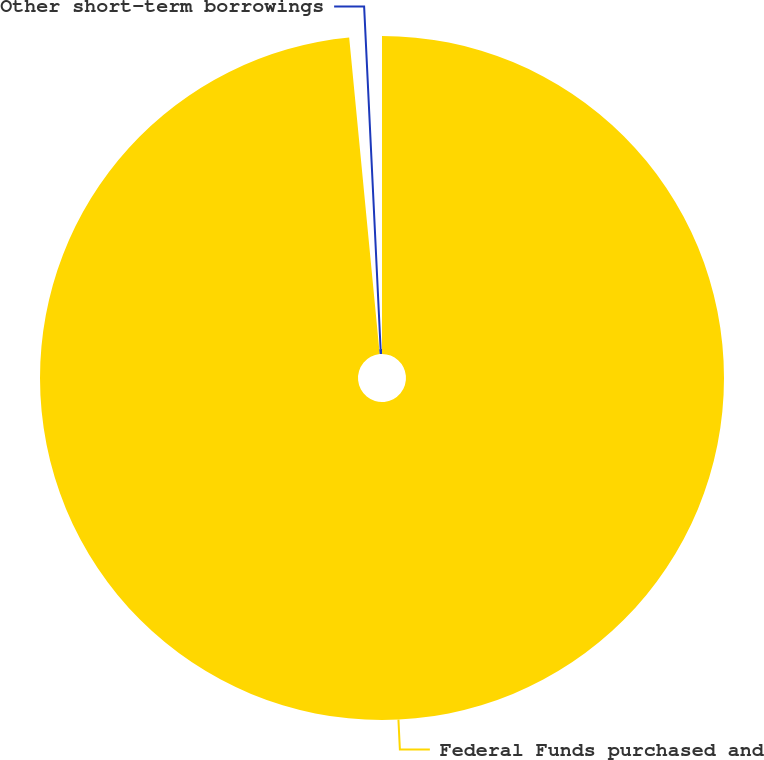<chart> <loc_0><loc_0><loc_500><loc_500><pie_chart><fcel>Federal Funds purchased and<fcel>Other short-term borrowings<nl><fcel>98.47%<fcel>1.53%<nl></chart> 